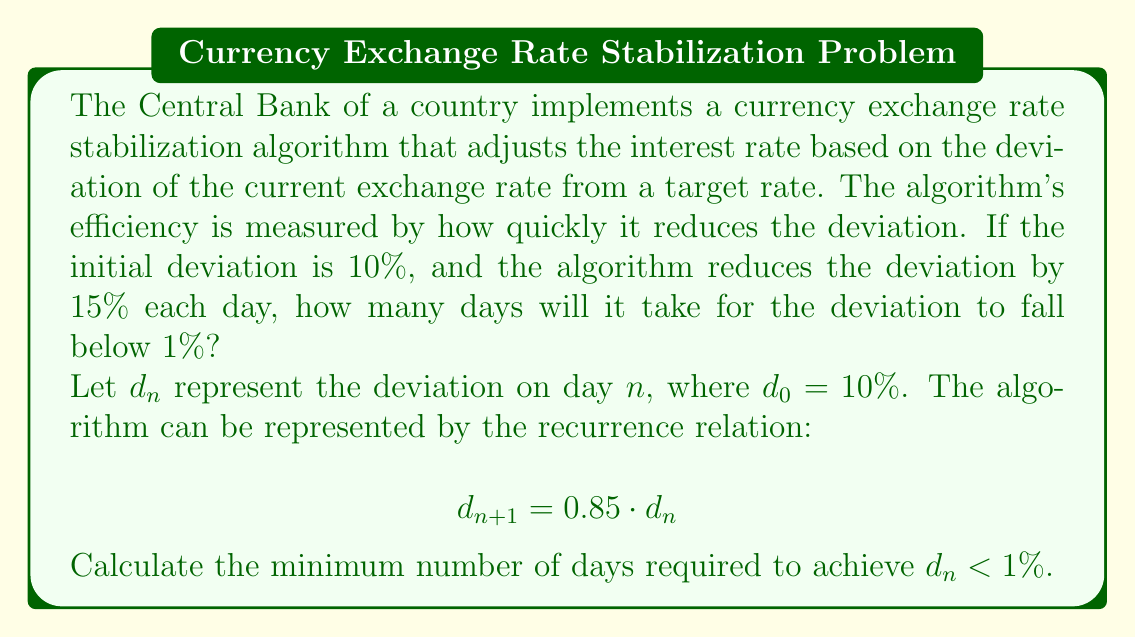Provide a solution to this math problem. To solve this problem, we need to use the given recurrence relation and determine when the deviation falls below 1%. Let's approach this step-by-step:

1) We start with $d_0 = 10\% = 0.1$

2) For each subsequent day, we multiply the previous day's deviation by 0.85:

   $d_1 = 0.85 \cdot 0.1 = 0.085$
   $d_2 = 0.85 \cdot 0.085 = 0.07225$
   $d_3 = 0.85 \cdot 0.07225 = 0.0614125$
   ...

3) We can generalize this as:

   $d_n = 0.1 \cdot (0.85)^n$

4) We want to find $n$ such that $d_n < 0.01$ (1%)

5) So, we need to solve:

   $0.1 \cdot (0.85)^n < 0.01$

6) Dividing both sides by 0.1:

   $(0.85)^n < 0.1$

7) Taking the natural log of both sides:

   $n \cdot \ln(0.85) < \ln(0.1)$

8) Solving for $n$:

   $n > \frac{\ln(0.1)}{\ln(0.85)} \approx 14.2067$

9) Since $n$ must be a whole number of days, we round up to the next integer.
Answer: The minimum number of days required for the deviation to fall below 1% is 15 days. 